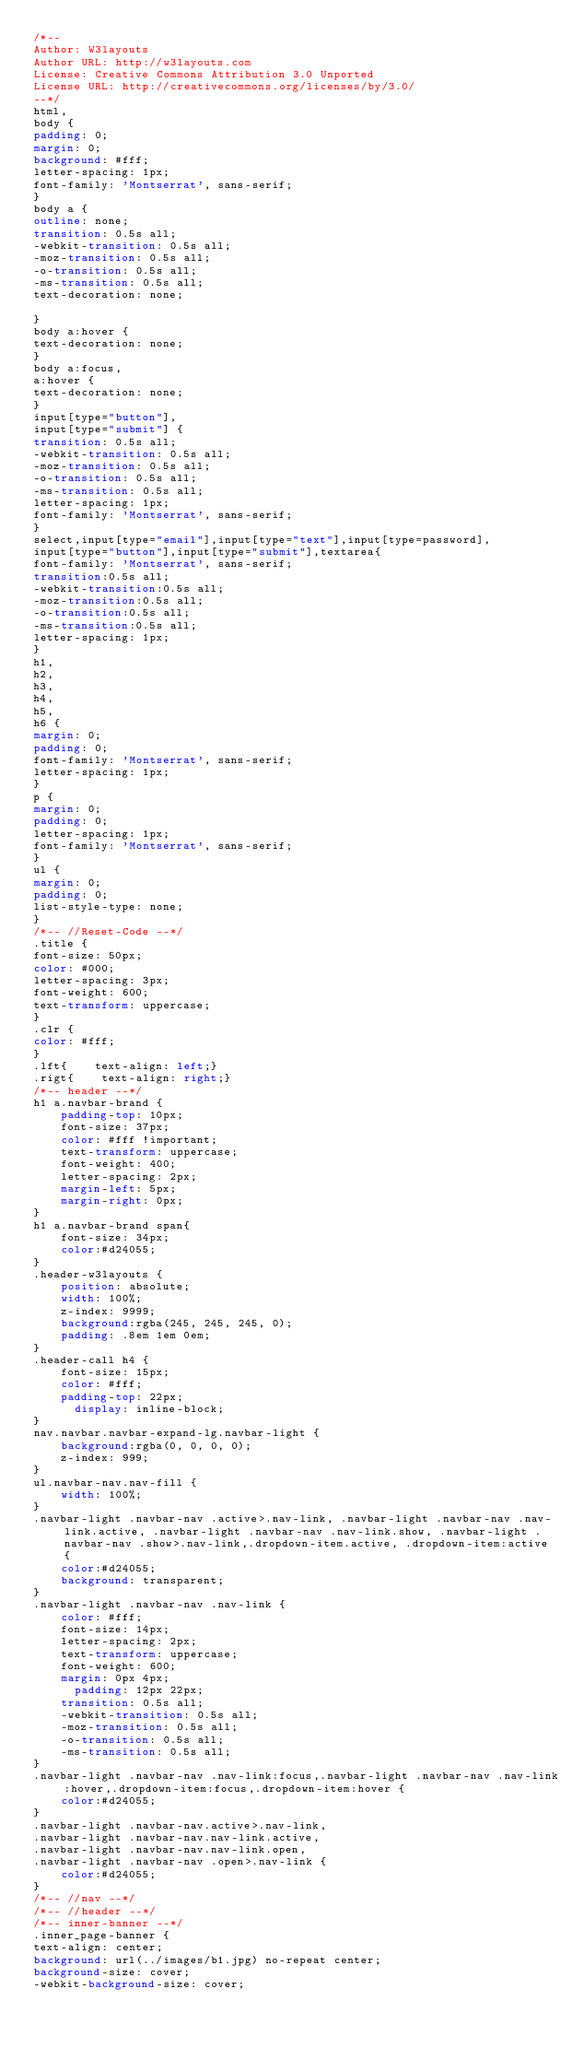<code> <loc_0><loc_0><loc_500><loc_500><_CSS_>/*--
Author: W3layouts
Author URL: http://w3layouts.com
License: Creative Commons Attribution 3.0 Unported
License URL: http://creativecommons.org/licenses/by/3.0/
--*/
html,
body {
padding: 0;
margin: 0;
background: #fff;
letter-spacing: 1px;
font-family: 'Montserrat', sans-serif;
}
body a {
outline: none;
transition: 0.5s all;
-webkit-transition: 0.5s all;
-moz-transition: 0.5s all;
-o-transition: 0.5s all;
-ms-transition: 0.5s all;
text-decoration: none;

}
body a:hover {
text-decoration: none;
}
body a:focus,
a:hover {
text-decoration: none;
}
input[type="button"],
input[type="submit"] {
transition: 0.5s all;
-webkit-transition: 0.5s all;
-moz-transition: 0.5s all;
-o-transition: 0.5s all;
-ms-transition: 0.5s all;
letter-spacing: 1px;
font-family: 'Montserrat', sans-serif;
}
select,input[type="email"],input[type="text"],input[type=password],
input[type="button"],input[type="submit"],textarea{
font-family: 'Montserrat', sans-serif;
transition:0.5s all;
-webkit-transition:0.5s all;
-moz-transition:0.5s all;
-o-transition:0.5s all;
-ms-transition:0.5s all;
letter-spacing: 1px;
}
h1,
h2,
h3,
h4,
h5,
h6 {
margin: 0;
padding: 0;
font-family: 'Montserrat', sans-serif;
letter-spacing: 1px;
}
p {
margin: 0;
padding: 0;
letter-spacing: 1px;
font-family: 'Montserrat', sans-serif;
}
ul {
margin: 0;
padding: 0;
list-style-type: none;
}
/*-- //Reset-Code --*/
.title {
font-size: 50px;
color: #000;
letter-spacing: 3px;
font-weight: 600;
text-transform: uppercase;
}
.clr {
color: #fff;
}
.lft{    text-align: left;}
.rigt{    text-align: right;}
/*-- header --*/ 
h1 a.navbar-brand {
    padding-top: 10px;
    font-size: 37px;
    color: #fff !important;
    text-transform: uppercase;
    font-weight: 400;
    letter-spacing: 2px;
    margin-left: 5px;
    margin-right: 0px;
}
h1 a.navbar-brand span{
    font-size: 34px;
    color:#d24055;
}
.header-w3layouts {
    position: absolute;
    width: 100%;
    z-index: 9999;
    background:rgba(245, 245, 245, 0);
    padding: .8em 1em 0em;
}
.header-call h4 {
    font-size: 15px;
    color: #fff;
    padding-top: 22px;
	    display: inline-block;
}
nav.navbar.navbar-expand-lg.navbar-light {
    background:rgba(0, 0, 0, 0);
    z-index: 999;
}
ul.navbar-nav.nav-fill {
    width: 100%;
}
.navbar-light .navbar-nav .active>.nav-link, .navbar-light .navbar-nav .nav-link.active, .navbar-light .navbar-nav .nav-link.show, .navbar-light .navbar-nav .show>.nav-link,.dropdown-item.active, .dropdown-item:active {
    color:#d24055;
    background: transparent;
}
.navbar-light .navbar-nav .nav-link {
    color: #fff;
    font-size: 14px;
    letter-spacing: 2px;
    text-transform: uppercase;
    font-weight: 600;
    margin: 0px 4px;
      padding: 12px 22px;
    transition: 0.5s all;
    -webkit-transition: 0.5s all;
    -moz-transition: 0.5s all;
    -o-transition: 0.5s all;
    -ms-transition: 0.5s all;
}
.navbar-light .navbar-nav .nav-link:focus,.navbar-light .navbar-nav .nav-link:hover,.dropdown-item:focus,.dropdown-item:hover {
    color:#d24055;
}
.navbar-light .navbar-nav.active>.nav-link,
.navbar-light .navbar-nav.nav-link.active, 
.navbar-light .navbar-nav.nav-link.open, 
.navbar-light .navbar-nav .open>.nav-link {
    color:#d24055;
}
/*-- //nav --*/
/*-- //header --*/ 
/*-- inner-banner --*/ 
.inner_page-banner {
text-align: center;
background: url(../images/b1.jpg) no-repeat center;
background-size: cover;
-webkit-background-size: cover;</code> 